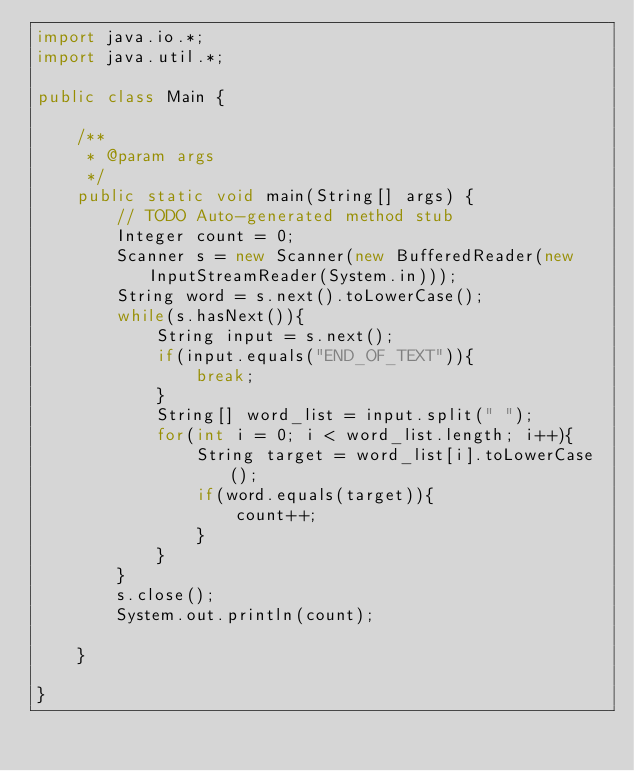Convert code to text. <code><loc_0><loc_0><loc_500><loc_500><_Java_>import java.io.*;
import java.util.*;

public class Main {

	/**
	 * @param args
	 */
	public static void main(String[] args) {
		// TODO Auto-generated method stub
		Integer count = 0;
		Scanner s = new Scanner(new BufferedReader(new InputStreamReader(System.in)));
		String word = s.next().toLowerCase();
		while(s.hasNext()){
			String input = s.next();
			if(input.equals("END_OF_TEXT")){
				break;
			}
			String[] word_list = input.split(" ");
			for(int i = 0; i < word_list.length; i++){
				String target = word_list[i].toLowerCase();
				if(word.equals(target)){
					count++;
				}
			}
		}
		s.close();
		System.out.println(count);

	}

}</code> 